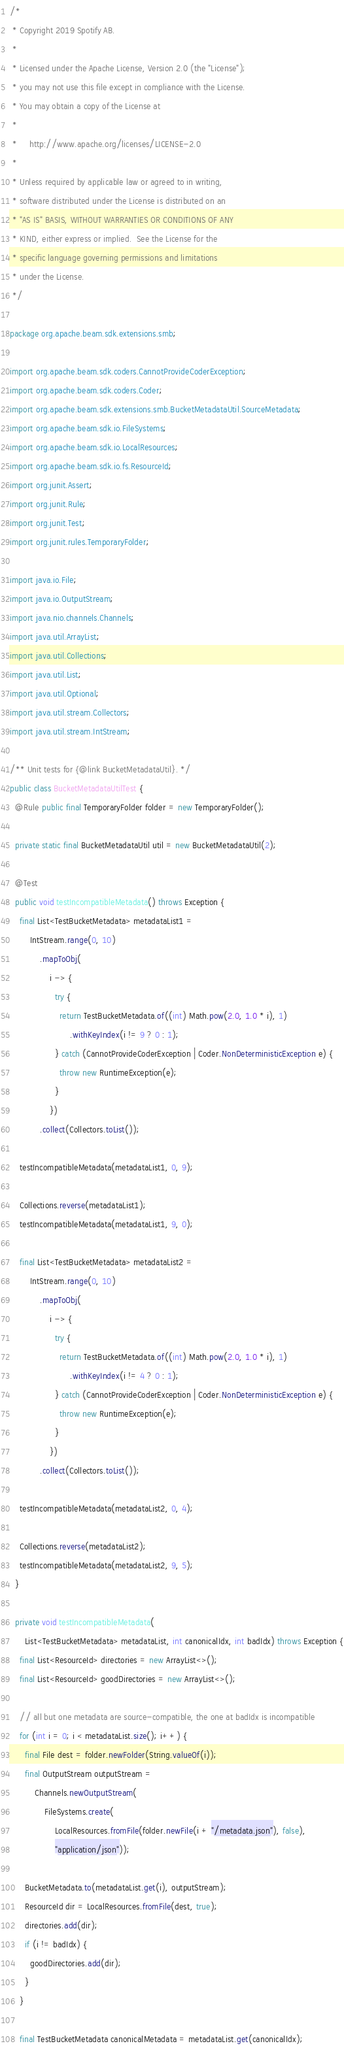<code> <loc_0><loc_0><loc_500><loc_500><_Java_>/*
 * Copyright 2019 Spotify AB.
 *
 * Licensed under the Apache License, Version 2.0 (the "License");
 * you may not use this file except in compliance with the License.
 * You may obtain a copy of the License at
 *
 *     http://www.apache.org/licenses/LICENSE-2.0
 *
 * Unless required by applicable law or agreed to in writing,
 * software distributed under the License is distributed on an
 * "AS IS" BASIS, WITHOUT WARRANTIES OR CONDITIONS OF ANY
 * KIND, either express or implied.  See the License for the
 * specific language governing permissions and limitations
 * under the License.
 */

package org.apache.beam.sdk.extensions.smb;

import org.apache.beam.sdk.coders.CannotProvideCoderException;
import org.apache.beam.sdk.coders.Coder;
import org.apache.beam.sdk.extensions.smb.BucketMetadataUtil.SourceMetadata;
import org.apache.beam.sdk.io.FileSystems;
import org.apache.beam.sdk.io.LocalResources;
import org.apache.beam.sdk.io.fs.ResourceId;
import org.junit.Assert;
import org.junit.Rule;
import org.junit.Test;
import org.junit.rules.TemporaryFolder;

import java.io.File;
import java.io.OutputStream;
import java.nio.channels.Channels;
import java.util.ArrayList;
import java.util.Collections;
import java.util.List;
import java.util.Optional;
import java.util.stream.Collectors;
import java.util.stream.IntStream;

/** Unit tests for {@link BucketMetadataUtil}. */
public class BucketMetadataUtilTest {
  @Rule public final TemporaryFolder folder = new TemporaryFolder();

  private static final BucketMetadataUtil util = new BucketMetadataUtil(2);

  @Test
  public void testIncompatibleMetadata() throws Exception {
    final List<TestBucketMetadata> metadataList1 =
        IntStream.range(0, 10)
            .mapToObj(
                i -> {
                  try {
                    return TestBucketMetadata.of((int) Math.pow(2.0, 1.0 * i), 1)
                        .withKeyIndex(i != 9 ? 0 : 1);
                  } catch (CannotProvideCoderException | Coder.NonDeterministicException e) {
                    throw new RuntimeException(e);
                  }
                })
            .collect(Collectors.toList());

    testIncompatibleMetadata(metadataList1, 0, 9);

    Collections.reverse(metadataList1);
    testIncompatibleMetadata(metadataList1, 9, 0);

    final List<TestBucketMetadata> metadataList2 =
        IntStream.range(0, 10)
            .mapToObj(
                i -> {
                  try {
                    return TestBucketMetadata.of((int) Math.pow(2.0, 1.0 * i), 1)
                        .withKeyIndex(i != 4 ? 0 : 1);
                  } catch (CannotProvideCoderException | Coder.NonDeterministicException e) {
                    throw new RuntimeException(e);
                  }
                })
            .collect(Collectors.toList());

    testIncompatibleMetadata(metadataList2, 0, 4);

    Collections.reverse(metadataList2);
    testIncompatibleMetadata(metadataList2, 9, 5);
  }

  private void testIncompatibleMetadata(
      List<TestBucketMetadata> metadataList, int canonicalIdx, int badIdx) throws Exception {
    final List<ResourceId> directories = new ArrayList<>();
    final List<ResourceId> goodDirectories = new ArrayList<>();

    // all but one metadata are source-compatible, the one at badIdx is incompatible
    for (int i = 0; i < metadataList.size(); i++) {
      final File dest = folder.newFolder(String.valueOf(i));
      final OutputStream outputStream =
          Channels.newOutputStream(
              FileSystems.create(
                  LocalResources.fromFile(folder.newFile(i + "/metadata.json"), false),
                  "application/json"));

      BucketMetadata.to(metadataList.get(i), outputStream);
      ResourceId dir = LocalResources.fromFile(dest, true);
      directories.add(dir);
      if (i != badIdx) {
        goodDirectories.add(dir);
      }
    }

    final TestBucketMetadata canonicalMetadata = metadataList.get(canonicalIdx);
</code> 